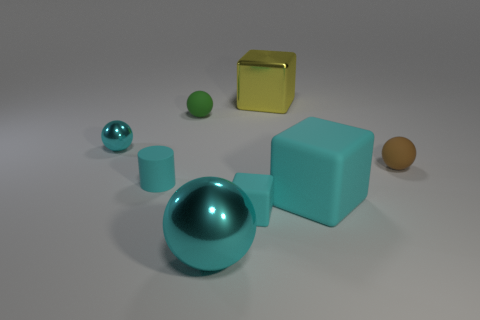Add 1 matte spheres. How many objects exist? 9 Subtract all cylinders. How many objects are left? 7 Subtract all small cyan rubber cubes. Subtract all big yellow blocks. How many objects are left? 6 Add 3 small rubber spheres. How many small rubber spheres are left? 5 Add 4 brown spheres. How many brown spheres exist? 5 Subtract 0 brown cubes. How many objects are left? 8 